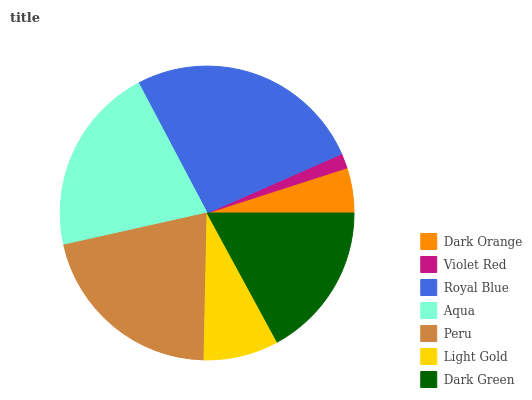Is Violet Red the minimum?
Answer yes or no. Yes. Is Royal Blue the maximum?
Answer yes or no. Yes. Is Royal Blue the minimum?
Answer yes or no. No. Is Violet Red the maximum?
Answer yes or no. No. Is Royal Blue greater than Violet Red?
Answer yes or no. Yes. Is Violet Red less than Royal Blue?
Answer yes or no. Yes. Is Violet Red greater than Royal Blue?
Answer yes or no. No. Is Royal Blue less than Violet Red?
Answer yes or no. No. Is Dark Green the high median?
Answer yes or no. Yes. Is Dark Green the low median?
Answer yes or no. Yes. Is Peru the high median?
Answer yes or no. No. Is Light Gold the low median?
Answer yes or no. No. 